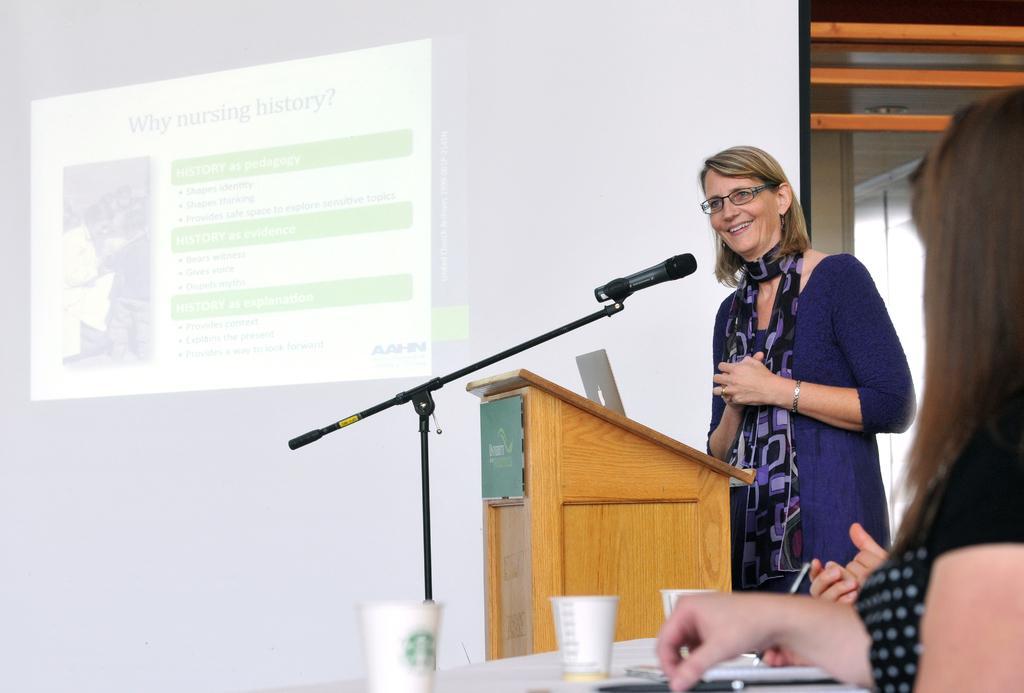How would you summarize this image in a sentence or two? In this picture we can see a woman wearing a blue dress standing near the wooden speech desk and smiling. Behind there is a white projector screen. In the front bottom side we can see a girl sitting and looking at her. 